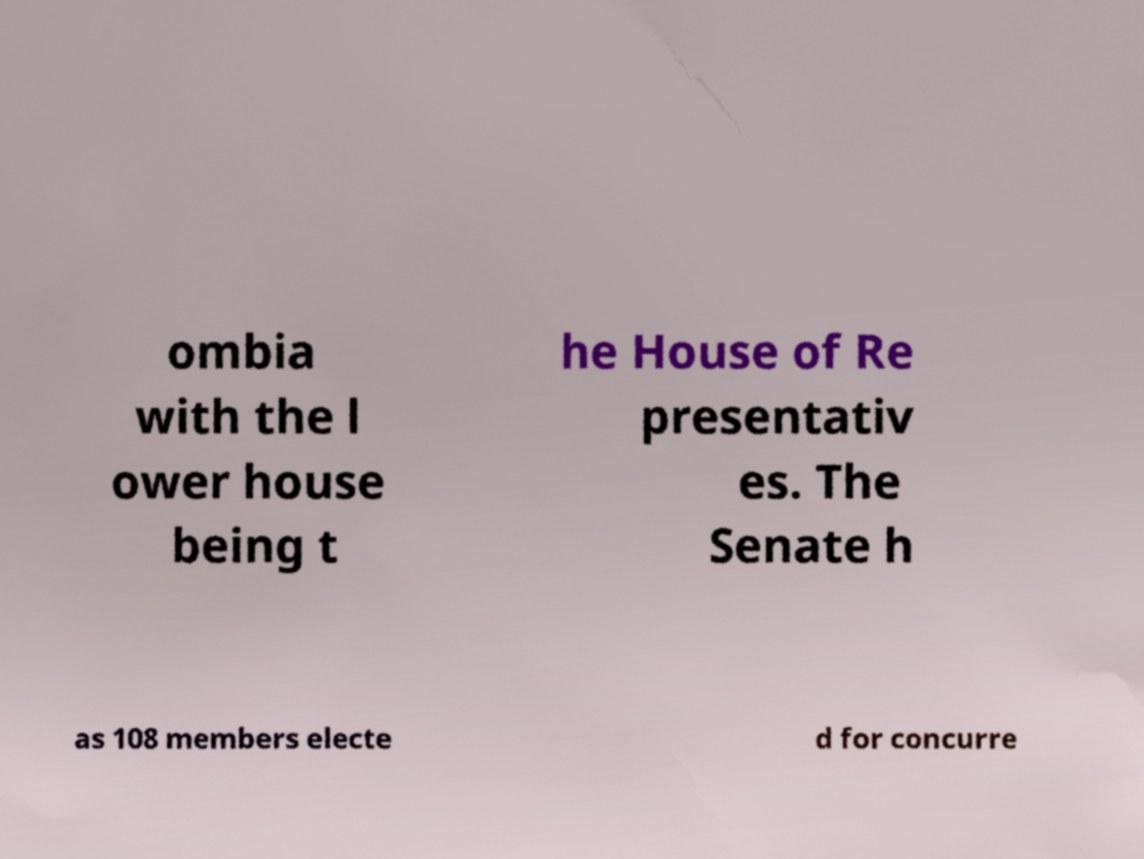Please read and relay the text visible in this image. What does it say? ombia with the l ower house being t he House of Re presentativ es. The Senate h as 108 members electe d for concurre 